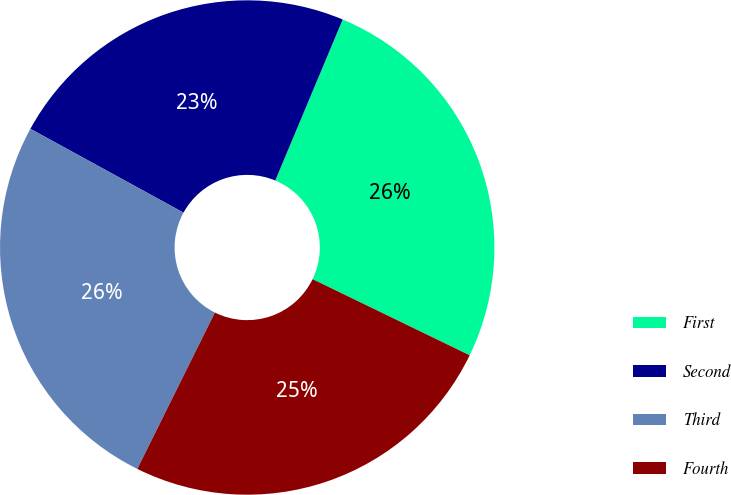Convert chart. <chart><loc_0><loc_0><loc_500><loc_500><pie_chart><fcel>First<fcel>Second<fcel>Third<fcel>Fourth<nl><fcel>25.87%<fcel>23.34%<fcel>25.64%<fcel>25.15%<nl></chart> 